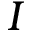<formula> <loc_0><loc_0><loc_500><loc_500>I</formula> 